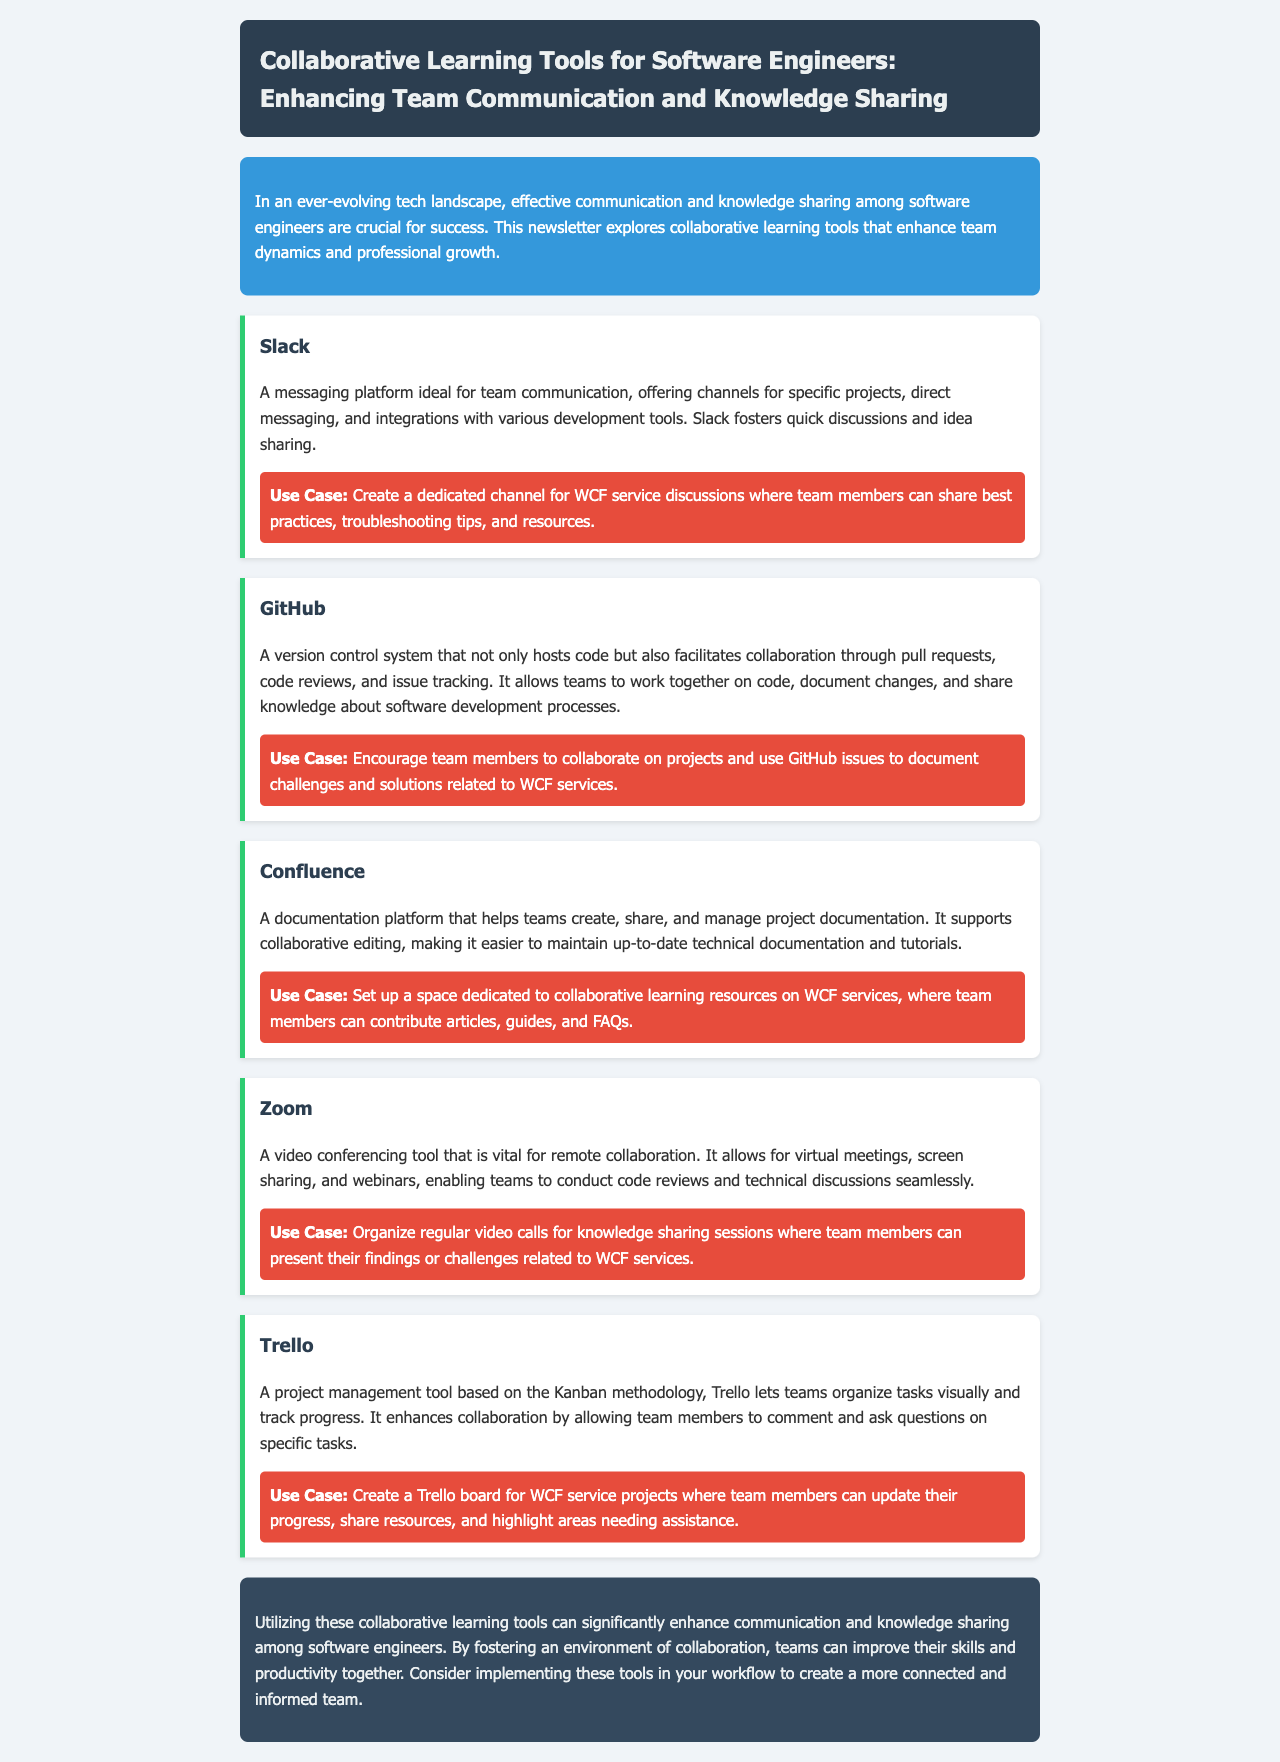What is the main topic of the newsletter? The main topic is about collaborative learning tools for enhancing teamwork among software engineers.
Answer: Collaborative Learning Tools for Software Engineers What platform is recommended for project documentation? The newsletter suggests a documentation platform that helps manage project documentation.
Answer: Confluence How many collaborative tools are mentioned in the newsletter? The newsletter lists several tools to enhance team communication and knowledge sharing.
Answer: Five What is the use case for Slack? The use case describes how Slack can be utilized for team discussions regarding specific topics.
Answer: Create a dedicated channel for WCF service discussions Which tool is described as a video conferencing solution? One of the tools outlined in the newsletter focuses on facilitating video meetings and screen sharing for remote collaboration.
Answer: Zoom What methodology does Trello utilize for project management? The newsletter specifies a particular methodology Trello is based on, which is popular for organizing tasks visually.
Answer: Kanban What is the purpose of Zoom according to the newsletter? Zoom serves a specific function related to team collaboration through virtual meetings.
Answer: Video conferencing What is suggested for promoting knowledge sharing sessions? The document proposes a specific action that can be organized for knowledge sharing among team members.
Answer: Regular video calls 